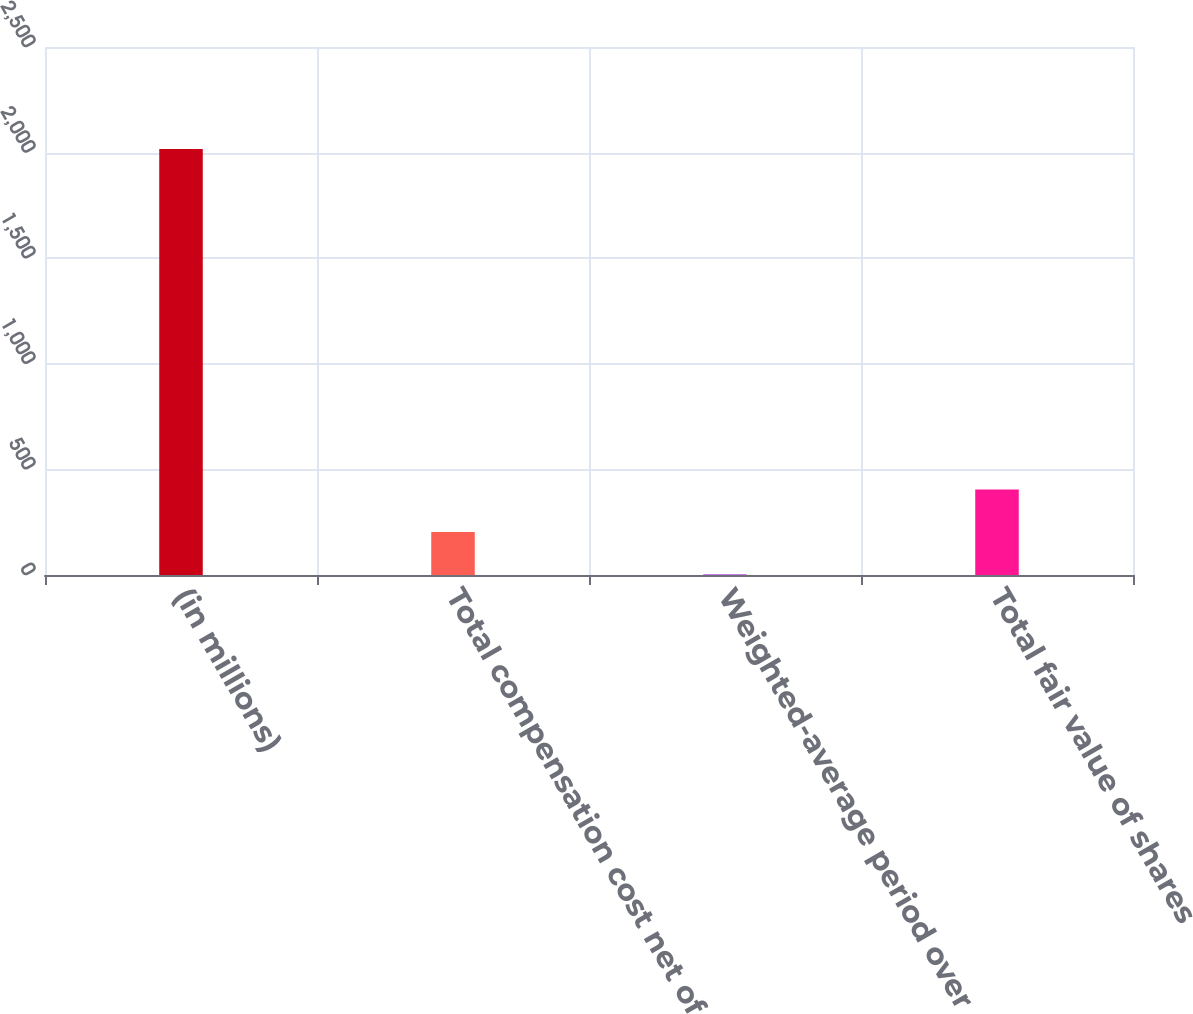Convert chart. <chart><loc_0><loc_0><loc_500><loc_500><bar_chart><fcel>(in millions)<fcel>Total compensation cost net of<fcel>Weighted-average period over<fcel>Total fair value of shares<nl><fcel>2017<fcel>203.5<fcel>2<fcel>405<nl></chart> 